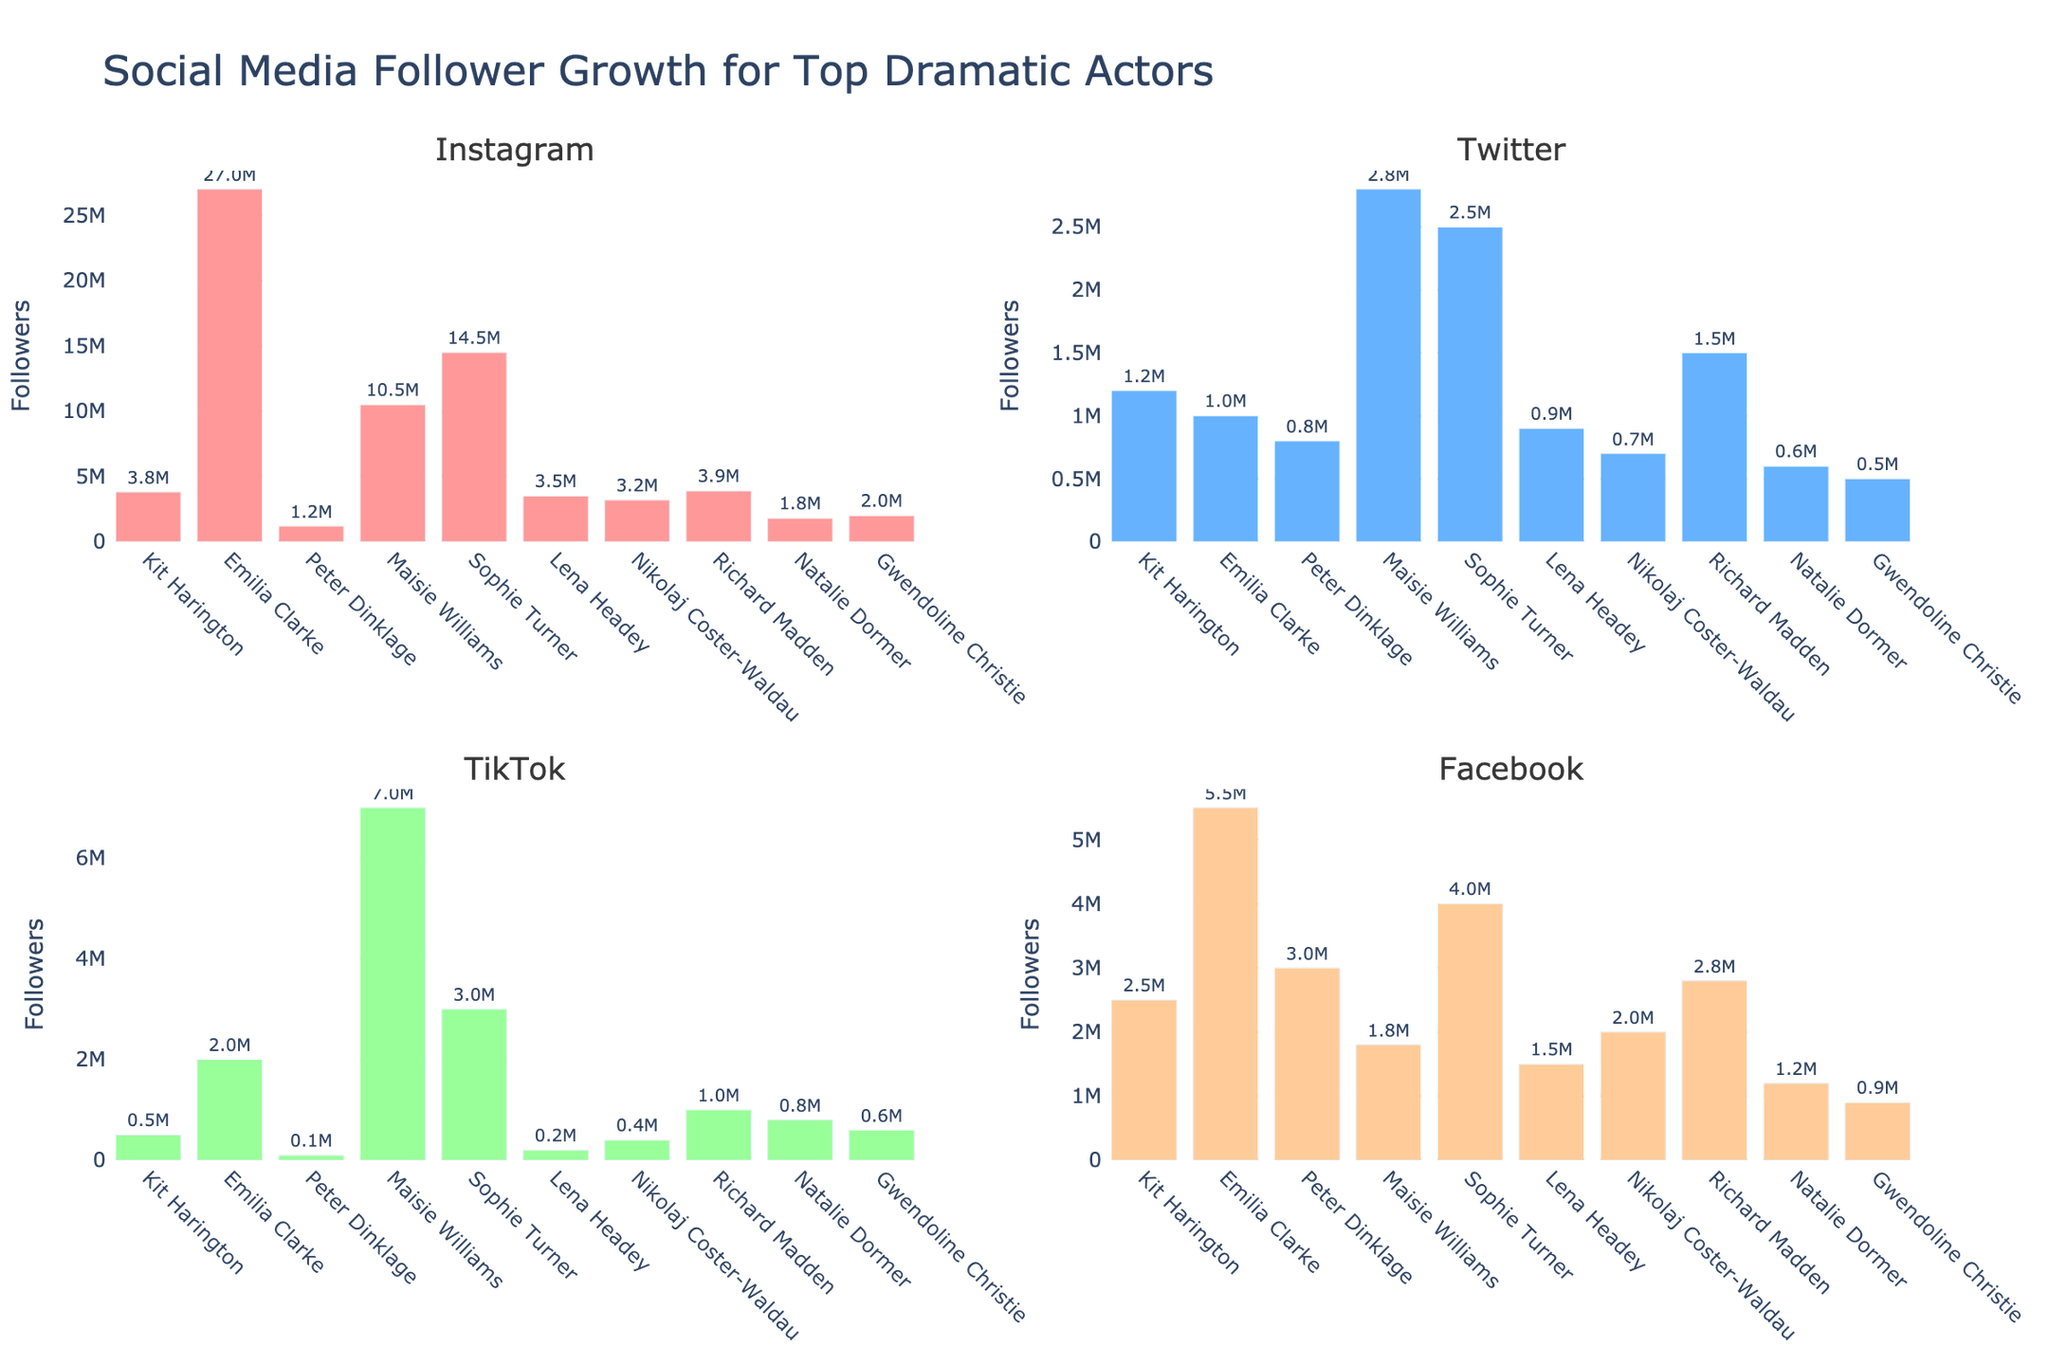Which actor has the highest number of Instagram followers? The Instagram subplot shows that Emilia Clarke has the tallest bar, indicating the highest number of Instagram followers among the actors.
Answer: Emilia Clarke What's the total number of TikTok followers for Maisie Williams and Kit Harington combined? According to the TikTok subplot, Maisie Williams has 7,000,000 followers, and Kit Harington has 500,000 followers. Adding these together, 7,000,000 + 500,000 = 7,500,000.
Answer: 7,500,000 Which actor has more Twitter followers: Sophie Turner or Richard Madden? The Twitter subplot shows that Sophie Turner has a bar indicating 2,500,000 followers, while Richard Madden's bar indicates 1,500,000 followers. Therefore, Sophie Turner has more Twitter followers.
Answer: Sophie Turner Who has the fewest Facebook followers and how many do they have? The Facebook subplot shows that Lena Headey has the shortest bar, indicating the fewest Facebook followers, which is 1,500,000.
Answer: Lena Headey, 1,500,000 What is the average number of Instagram followers for the actors? To determine the average, sum all the Instagram followers and divide by the number of actors. The Instagram followers are: 3,800,000 (Kit Harington) + 27,000,000 (Emilia Clarke) + 1,200,000 (Peter Dinklage) + 10,500,000 (Maisie Williams) + 14,500,000 (Sophie Turner) + 3,500,000 (Lena Headey) + 3,200,000 (Nikolaj Coster-Waldau) + 3,900,000 (Richard Madden) + 1,800,000 (Natalie Dormer) + 2,000,000 (Gwendoline Christie). The total is 71,400,000; dividing by 10 actors, the average is 7,140,000.
Answer: 7,140,000 Which actor has the largest difference between their Instagram and Facebook followers? To find the largest difference, calculate the difference for each actor and compare: Kit Harington: 1,300,000; Emilia Clarke: 21,500,000; Peter Dinklage: 1,800,000; Maisie Williams: 8,700,000; Sophie Turner: 10,500,000; Lena Headey: 2,000,000; Nikolaj Coster-Waldau: 1,200,000; Richard Madden: 1,100,000; Natalie Dormer: 600,000; Gwendoline Christie: 1,100,000. Emilia Clarke has the largest difference of 21,500,000.
Answer: Emilia Clarke Does Gwendoline Christie have more followers on Twitter or TikTok? Gwendoline Christie's Twitter bar shows 500,000 followers, while her TikTok bar shows 600,000 followers. Therefore, she has more followers on TikTok.
Answer: TikTok What is the ratio of Lena Headey's Instagram followers to her TikTok followers? Lena Headey has 3,500,000 Instagram followers and 200,000 TikTok followers. The ratio is 3,500,000:200,000, which simplifies to 17.5:1.
Answer: 17.5:1 If you sum the Facebook followers for Peter Dinklage and Sophie Turner, what is the value? Peter Dinklage has 3,000,000 Facebook followers, and Sophie Turner has 4,000,000 Facebook followers. Summing these gives 3,000,000 + 4,000,000 = 7,000,000.
Answer: 7,000,000 